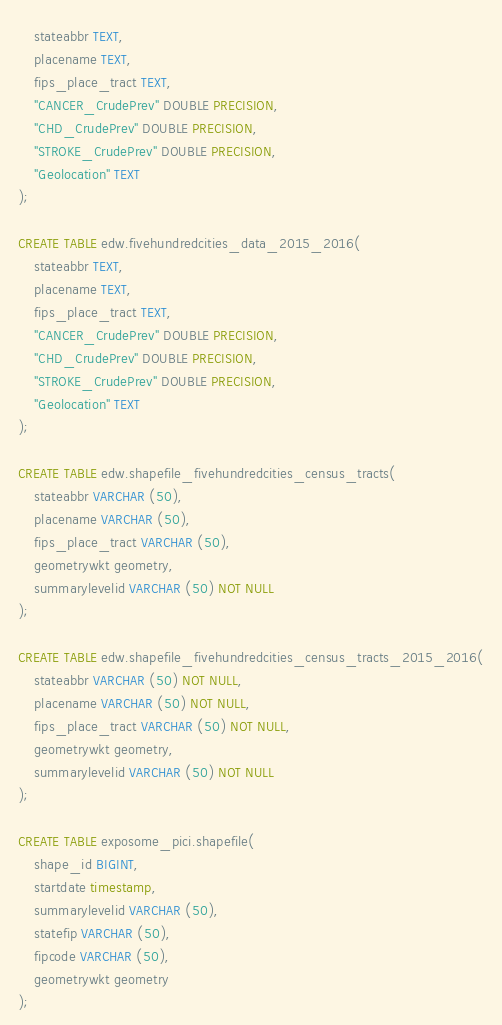Convert code to text. <code><loc_0><loc_0><loc_500><loc_500><_SQL_>	stateabbr TEXT,
	placename TEXT,
	fips_place_tract TEXT,
	"CANCER_CrudePrev" DOUBLE PRECISION,
	"CHD_CrudePrev" DOUBLE PRECISION,
	"STROKE_CrudePrev" DOUBLE PRECISION,
	"Geolocation" TEXT
);

CREATE TABLE edw.fivehundredcities_data_2015_2016(
	stateabbr TEXT,
	placename TEXT,
	fips_place_tract TEXT,
	"CANCER_CrudePrev" DOUBLE PRECISION,
	"CHD_CrudePrev" DOUBLE PRECISION,
	"STROKE_CrudePrev" DOUBLE PRECISION,
	"Geolocation" TEXT
);

CREATE TABLE edw.shapefile_fivehundredcities_census_tracts(
	stateabbr VARCHAR (50),
	placename VARCHAR (50),
	fips_place_tract VARCHAR (50),
	geometrywkt geometry,
	summarylevelid VARCHAR (50) NOT NULL
);

CREATE TABLE edw.shapefile_fivehundredcities_census_tracts_2015_2016(
	stateabbr VARCHAR (50) NOT NULL,
	placename VARCHAR (50) NOT NULL,
	fips_place_tract VARCHAR (50) NOT NULL,
	geometrywkt geometry,
	summarylevelid VARCHAR (50) NOT NULL
);

CREATE TABLE exposome_pici.shapefile(
	shape_id BIGINT,
	startdate timestamp,
	summarylevelid VARCHAR (50),
	statefip VARCHAR (50),
	fipcode VARCHAR (50),
	geometrywkt geometry
);
</code> 